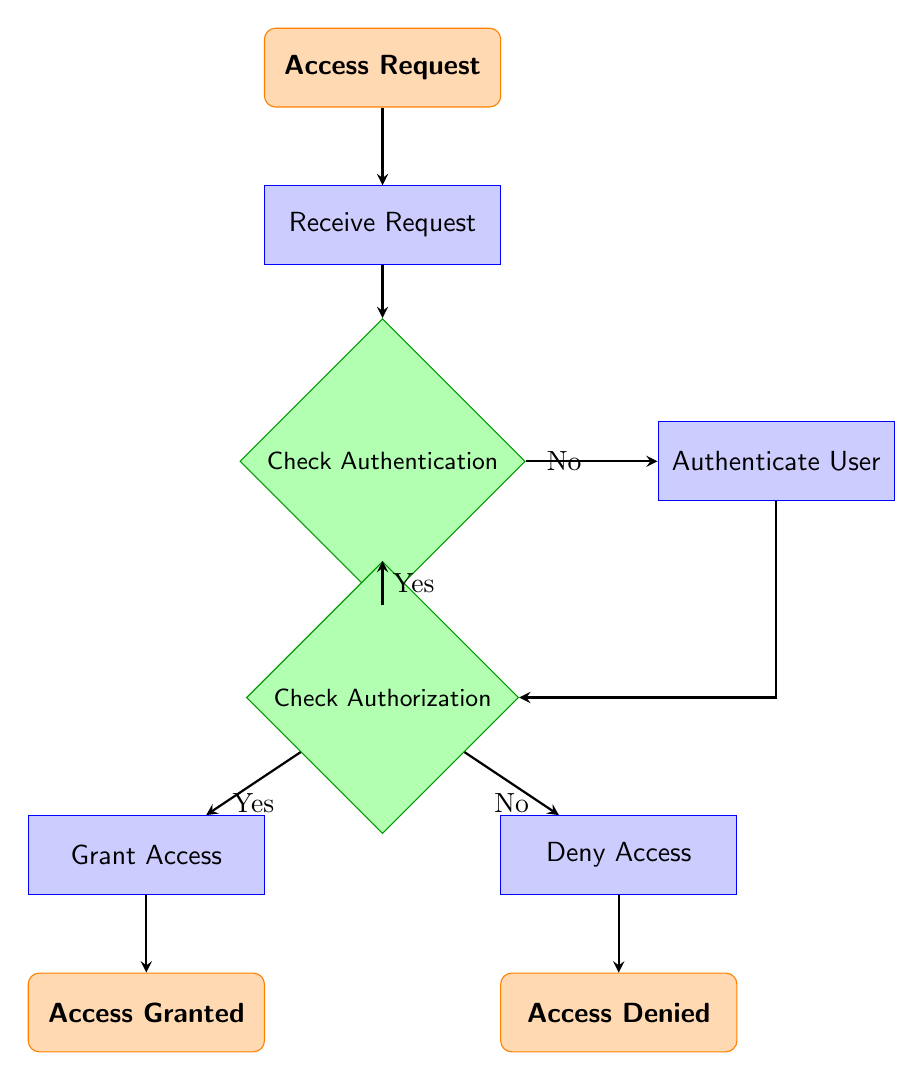What is the initial node in the flow chart? The initial node in the flow chart is the "Access Request". This is the starting point where the process begins based on the diagram.
Answer: Access Request How many process nodes are in the flow chart? By counting the nodes classified as "process" in the diagram, we find there are four process nodes: "Receive Request", "Authenticate User", "Grant Access", and "Deny Access".
Answer: Four What happens if the user is authenticated? If the user is authenticated (i.e., the answer to "Check Authentication" is Yes), the flow proceeds to the next decision node, which is "Check Authorization".
Answer: Check Authorization Which node is reached if the user is not authenticated? If the user is not authenticated (i.e., the answer to "Check Authentication" is No), the flow goes to the "Authenticate User" process. This verifies the user's credentials next.
Answer: Authenticate User After successful authorization, what is the next step? After a successful "Check Authorization" (answer is Yes), the next step in the flow is to "Grant Access", where the requested access is granted to the user.
Answer: Grant Access How many end nodes are there in the diagram? The diagram contains two end nodes: "Access Granted" and "Access Denied". Both represent the conclusion of the access request flow under different outcomes.
Answer: Two What is the outcome if the user does not have the required role? If the user does not have the required role (decision "Check Authorization" is No), the flow leads to the "Deny Access" process, which indicates that access is not allowed.
Answer: Deny Access What condition leads to the "Access Granted" node? The condition leading to the "Access Granted" node is a Yes response to the "Check Authorization" decision, indicating the user has the required role.
Answer: Yes How is the flow from "Receive Request" to "Check Authentication"? The flow moves directly from "Receive Request" to "Check Authentication" with a single arrow representing a sequential step in the process.
Answer: Directly 